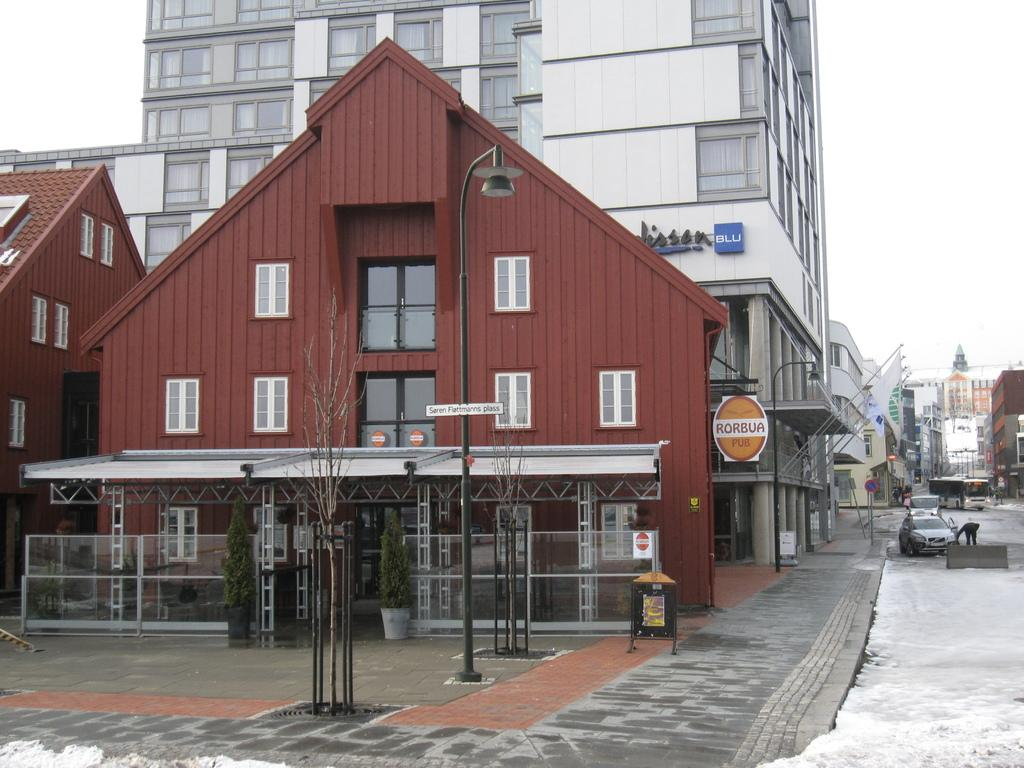What type of structures can be seen in the image? There are buildings in the image. What type of objects are present for decoration or gardening purposes? There are potted plants in the image. What type of vertical structures can be seen in the image? There are poles in the image. What type of illumination is present in the image? There are lights in the image. What type of openings can be seen in the buildings? There are windows in the image. What type of transportation is visible in the image? There are vehicles in the image. What type of natural elements can be seen in the image? There are trees in the image. What type of signage is present in the image? There are boards with text in the image. What can be seen in the background of the image? The sky is visible in the background of the image. How many bulbs are present in the image? There is no mention of bulbs in the image; it only mentions lights. What type of emotion is being expressed by the buildings in the image? Buildings do not express emotions; they are inanimate objects. 